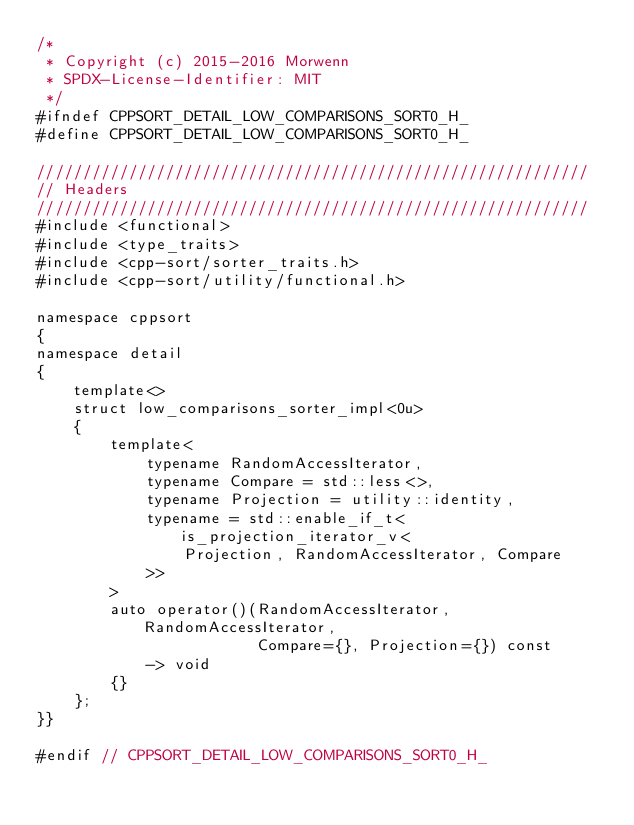Convert code to text. <code><loc_0><loc_0><loc_500><loc_500><_C_>/*
 * Copyright (c) 2015-2016 Morwenn
 * SPDX-License-Identifier: MIT
 */
#ifndef CPPSORT_DETAIL_LOW_COMPARISONS_SORT0_H_
#define CPPSORT_DETAIL_LOW_COMPARISONS_SORT0_H_

////////////////////////////////////////////////////////////
// Headers
////////////////////////////////////////////////////////////
#include <functional>
#include <type_traits>
#include <cpp-sort/sorter_traits.h>
#include <cpp-sort/utility/functional.h>

namespace cppsort
{
namespace detail
{
    template<>
    struct low_comparisons_sorter_impl<0u>
    {
        template<
            typename RandomAccessIterator,
            typename Compare = std::less<>,
            typename Projection = utility::identity,
            typename = std::enable_if_t<is_projection_iterator_v<
                Projection, RandomAccessIterator, Compare
            >>
        >
        auto operator()(RandomAccessIterator, RandomAccessIterator,
                        Compare={}, Projection={}) const
            -> void
        {}
    };
}}

#endif // CPPSORT_DETAIL_LOW_COMPARISONS_SORT0_H_
</code> 